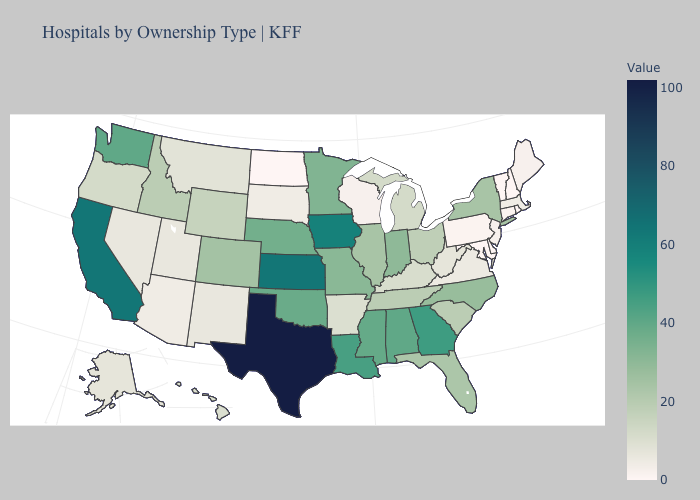Among the states that border Arkansas , does Texas have the highest value?
Short answer required. Yes. Does Texas have the highest value in the USA?
Write a very short answer. Yes. Among the states that border Maryland , does Virginia have the highest value?
Short answer required. No. Which states hav the highest value in the South?
Quick response, please. Texas. Which states have the lowest value in the USA?
Write a very short answer. Delaware, Maryland, New Hampshire, North Dakota, Rhode Island, Vermont. 